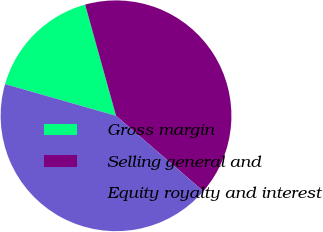Convert chart. <chart><loc_0><loc_0><loc_500><loc_500><pie_chart><fcel>Gross margin<fcel>Selling general and<fcel>Equity royalty and interest<nl><fcel>16.26%<fcel>40.65%<fcel>43.09%<nl></chart> 